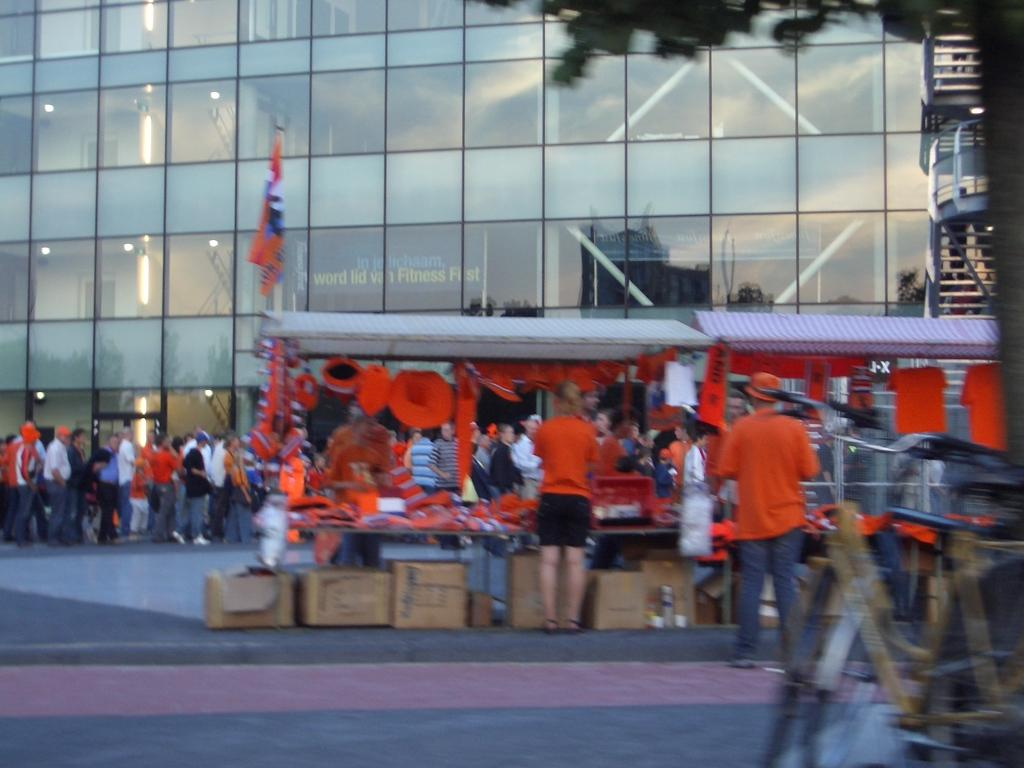What type of structures are present in the image? There are stalls in the image. Can you describe the people in the image? There are people on the surface in the image. What can be seen in the background of the image? There is a building in the background of the image. What mode of transportation is visible on the right side of the image? There are bicycles on the right side of the image. What type of curtain can be seen hanging from the stalls in the image? There is no curtain present in the image; it features stalls, people, a building, and bicycles. How does the glove provide pleasure to the people in the image? There is no glove present in the image, and therefore no such pleasure can be observed. 